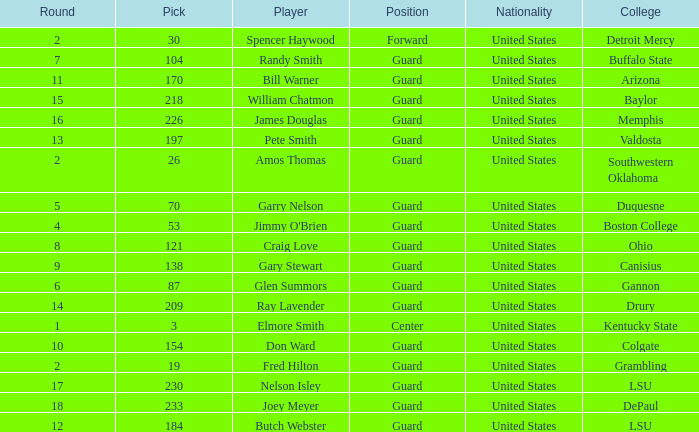WHAT IS THE NATIONALITY FOR SOUTHWESTERN OKLAHOMA? United States. 